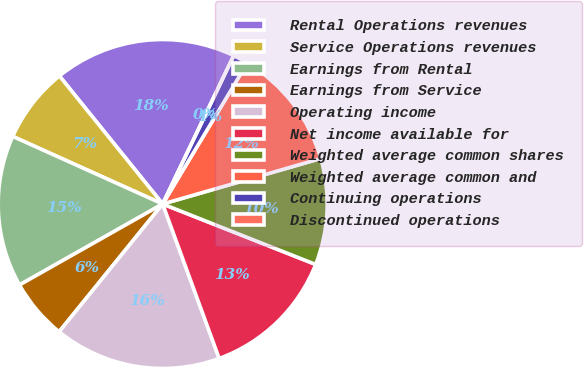Convert chart. <chart><loc_0><loc_0><loc_500><loc_500><pie_chart><fcel>Rental Operations revenues<fcel>Service Operations revenues<fcel>Earnings from Rental<fcel>Earnings from Service<fcel>Operating income<fcel>Net income available for<fcel>Weighted average common shares<fcel>Weighted average common and<fcel>Continuing operations<fcel>Discontinued operations<nl><fcel>17.91%<fcel>7.46%<fcel>14.93%<fcel>5.97%<fcel>16.42%<fcel>13.43%<fcel>10.45%<fcel>11.94%<fcel>1.49%<fcel>0.0%<nl></chart> 